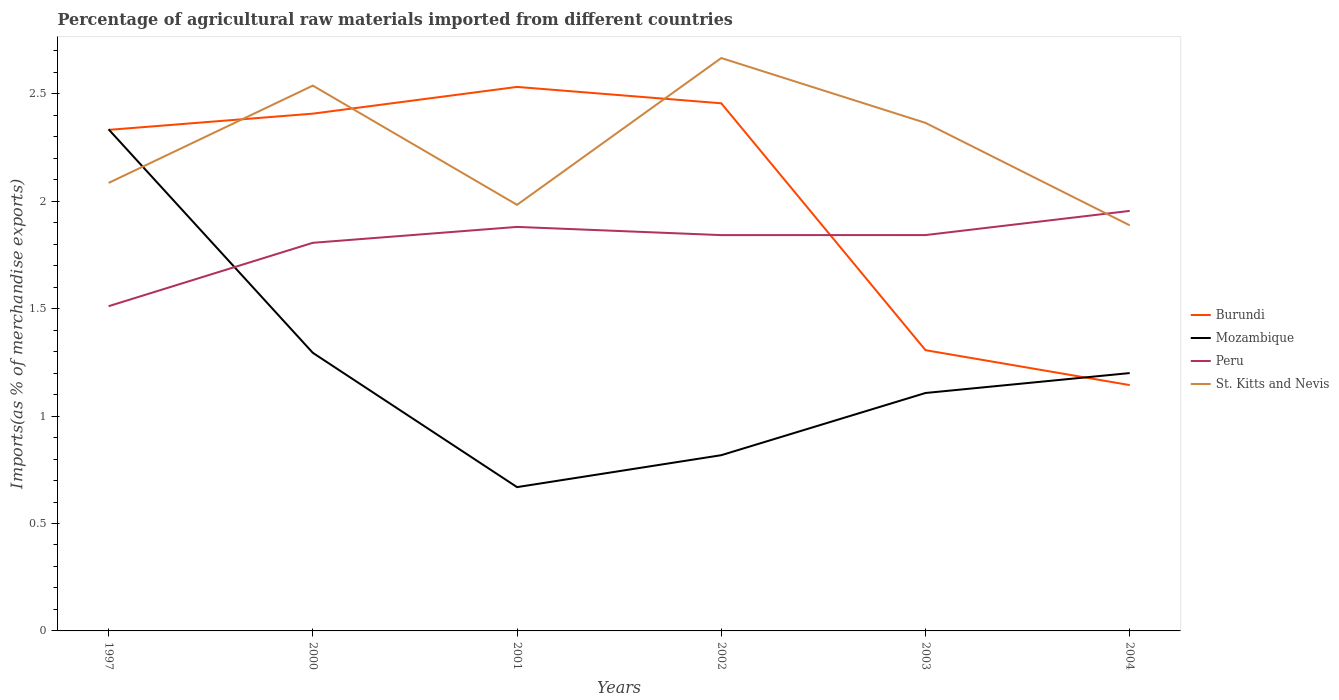Across all years, what is the maximum percentage of imports to different countries in Burundi?
Your answer should be compact. 1.14. In which year was the percentage of imports to different countries in Peru maximum?
Keep it short and to the point. 1997. What is the total percentage of imports to different countries in St. Kitts and Nevis in the graph?
Offer a terse response. -0.45. What is the difference between the highest and the second highest percentage of imports to different countries in St. Kitts and Nevis?
Keep it short and to the point. 0.78. What is the difference between the highest and the lowest percentage of imports to different countries in Burundi?
Provide a succinct answer. 4. Is the percentage of imports to different countries in St. Kitts and Nevis strictly greater than the percentage of imports to different countries in Burundi over the years?
Offer a terse response. No. How many lines are there?
Offer a terse response. 4. How many years are there in the graph?
Ensure brevity in your answer.  6. Does the graph contain any zero values?
Your response must be concise. No. Does the graph contain grids?
Your answer should be very brief. No. Where does the legend appear in the graph?
Provide a succinct answer. Center right. How many legend labels are there?
Give a very brief answer. 4. How are the legend labels stacked?
Offer a very short reply. Vertical. What is the title of the graph?
Keep it short and to the point. Percentage of agricultural raw materials imported from different countries. What is the label or title of the Y-axis?
Your answer should be compact. Imports(as % of merchandise exports). What is the Imports(as % of merchandise exports) of Burundi in 1997?
Provide a short and direct response. 2.33. What is the Imports(as % of merchandise exports) in Mozambique in 1997?
Ensure brevity in your answer.  2.33. What is the Imports(as % of merchandise exports) of Peru in 1997?
Provide a succinct answer. 1.51. What is the Imports(as % of merchandise exports) of St. Kitts and Nevis in 1997?
Offer a terse response. 2.09. What is the Imports(as % of merchandise exports) of Burundi in 2000?
Offer a very short reply. 2.41. What is the Imports(as % of merchandise exports) of Mozambique in 2000?
Give a very brief answer. 1.29. What is the Imports(as % of merchandise exports) of Peru in 2000?
Offer a very short reply. 1.81. What is the Imports(as % of merchandise exports) of St. Kitts and Nevis in 2000?
Your response must be concise. 2.54. What is the Imports(as % of merchandise exports) in Burundi in 2001?
Offer a very short reply. 2.53. What is the Imports(as % of merchandise exports) of Mozambique in 2001?
Your answer should be very brief. 0.67. What is the Imports(as % of merchandise exports) in Peru in 2001?
Ensure brevity in your answer.  1.88. What is the Imports(as % of merchandise exports) of St. Kitts and Nevis in 2001?
Provide a short and direct response. 1.98. What is the Imports(as % of merchandise exports) of Burundi in 2002?
Provide a short and direct response. 2.46. What is the Imports(as % of merchandise exports) in Mozambique in 2002?
Make the answer very short. 0.82. What is the Imports(as % of merchandise exports) of Peru in 2002?
Your response must be concise. 1.84. What is the Imports(as % of merchandise exports) in St. Kitts and Nevis in 2002?
Provide a succinct answer. 2.67. What is the Imports(as % of merchandise exports) of Burundi in 2003?
Offer a terse response. 1.31. What is the Imports(as % of merchandise exports) of Mozambique in 2003?
Your answer should be compact. 1.11. What is the Imports(as % of merchandise exports) of Peru in 2003?
Ensure brevity in your answer.  1.84. What is the Imports(as % of merchandise exports) in St. Kitts and Nevis in 2003?
Provide a short and direct response. 2.36. What is the Imports(as % of merchandise exports) in Burundi in 2004?
Provide a short and direct response. 1.14. What is the Imports(as % of merchandise exports) in Mozambique in 2004?
Give a very brief answer. 1.2. What is the Imports(as % of merchandise exports) in Peru in 2004?
Offer a very short reply. 1.95. What is the Imports(as % of merchandise exports) of St. Kitts and Nevis in 2004?
Offer a very short reply. 1.89. Across all years, what is the maximum Imports(as % of merchandise exports) of Burundi?
Keep it short and to the point. 2.53. Across all years, what is the maximum Imports(as % of merchandise exports) of Mozambique?
Offer a terse response. 2.33. Across all years, what is the maximum Imports(as % of merchandise exports) in Peru?
Your answer should be very brief. 1.95. Across all years, what is the maximum Imports(as % of merchandise exports) of St. Kitts and Nevis?
Make the answer very short. 2.67. Across all years, what is the minimum Imports(as % of merchandise exports) of Burundi?
Provide a short and direct response. 1.14. Across all years, what is the minimum Imports(as % of merchandise exports) of Mozambique?
Provide a short and direct response. 0.67. Across all years, what is the minimum Imports(as % of merchandise exports) in Peru?
Your answer should be very brief. 1.51. Across all years, what is the minimum Imports(as % of merchandise exports) of St. Kitts and Nevis?
Your response must be concise. 1.89. What is the total Imports(as % of merchandise exports) of Burundi in the graph?
Your answer should be compact. 12.18. What is the total Imports(as % of merchandise exports) of Mozambique in the graph?
Provide a short and direct response. 7.42. What is the total Imports(as % of merchandise exports) in Peru in the graph?
Offer a very short reply. 10.84. What is the total Imports(as % of merchandise exports) of St. Kitts and Nevis in the graph?
Offer a terse response. 13.52. What is the difference between the Imports(as % of merchandise exports) in Burundi in 1997 and that in 2000?
Give a very brief answer. -0.08. What is the difference between the Imports(as % of merchandise exports) of Mozambique in 1997 and that in 2000?
Make the answer very short. 1.04. What is the difference between the Imports(as % of merchandise exports) in Peru in 1997 and that in 2000?
Offer a very short reply. -0.29. What is the difference between the Imports(as % of merchandise exports) in St. Kitts and Nevis in 1997 and that in 2000?
Give a very brief answer. -0.45. What is the difference between the Imports(as % of merchandise exports) in Burundi in 1997 and that in 2001?
Give a very brief answer. -0.2. What is the difference between the Imports(as % of merchandise exports) in Mozambique in 1997 and that in 2001?
Make the answer very short. 1.67. What is the difference between the Imports(as % of merchandise exports) in Peru in 1997 and that in 2001?
Give a very brief answer. -0.37. What is the difference between the Imports(as % of merchandise exports) in St. Kitts and Nevis in 1997 and that in 2001?
Provide a succinct answer. 0.1. What is the difference between the Imports(as % of merchandise exports) in Burundi in 1997 and that in 2002?
Offer a very short reply. -0.12. What is the difference between the Imports(as % of merchandise exports) in Mozambique in 1997 and that in 2002?
Your answer should be compact. 1.52. What is the difference between the Imports(as % of merchandise exports) in Peru in 1997 and that in 2002?
Offer a very short reply. -0.33. What is the difference between the Imports(as % of merchandise exports) in St. Kitts and Nevis in 1997 and that in 2002?
Your answer should be compact. -0.58. What is the difference between the Imports(as % of merchandise exports) of Burundi in 1997 and that in 2003?
Keep it short and to the point. 1.03. What is the difference between the Imports(as % of merchandise exports) in Mozambique in 1997 and that in 2003?
Give a very brief answer. 1.23. What is the difference between the Imports(as % of merchandise exports) in Peru in 1997 and that in 2003?
Make the answer very short. -0.33. What is the difference between the Imports(as % of merchandise exports) of St. Kitts and Nevis in 1997 and that in 2003?
Offer a very short reply. -0.28. What is the difference between the Imports(as % of merchandise exports) of Burundi in 1997 and that in 2004?
Ensure brevity in your answer.  1.19. What is the difference between the Imports(as % of merchandise exports) in Mozambique in 1997 and that in 2004?
Offer a very short reply. 1.13. What is the difference between the Imports(as % of merchandise exports) of Peru in 1997 and that in 2004?
Your answer should be compact. -0.44. What is the difference between the Imports(as % of merchandise exports) in St. Kitts and Nevis in 1997 and that in 2004?
Your answer should be compact. 0.2. What is the difference between the Imports(as % of merchandise exports) of Burundi in 2000 and that in 2001?
Ensure brevity in your answer.  -0.12. What is the difference between the Imports(as % of merchandise exports) of Mozambique in 2000 and that in 2001?
Ensure brevity in your answer.  0.62. What is the difference between the Imports(as % of merchandise exports) in Peru in 2000 and that in 2001?
Keep it short and to the point. -0.07. What is the difference between the Imports(as % of merchandise exports) in St. Kitts and Nevis in 2000 and that in 2001?
Provide a succinct answer. 0.55. What is the difference between the Imports(as % of merchandise exports) of Burundi in 2000 and that in 2002?
Offer a terse response. -0.05. What is the difference between the Imports(as % of merchandise exports) in Mozambique in 2000 and that in 2002?
Provide a succinct answer. 0.48. What is the difference between the Imports(as % of merchandise exports) in Peru in 2000 and that in 2002?
Offer a very short reply. -0.04. What is the difference between the Imports(as % of merchandise exports) of St. Kitts and Nevis in 2000 and that in 2002?
Your answer should be very brief. -0.13. What is the difference between the Imports(as % of merchandise exports) of Burundi in 2000 and that in 2003?
Provide a short and direct response. 1.1. What is the difference between the Imports(as % of merchandise exports) of Mozambique in 2000 and that in 2003?
Ensure brevity in your answer.  0.19. What is the difference between the Imports(as % of merchandise exports) of Peru in 2000 and that in 2003?
Keep it short and to the point. -0.04. What is the difference between the Imports(as % of merchandise exports) of St. Kitts and Nevis in 2000 and that in 2003?
Provide a short and direct response. 0.17. What is the difference between the Imports(as % of merchandise exports) in Burundi in 2000 and that in 2004?
Your answer should be compact. 1.26. What is the difference between the Imports(as % of merchandise exports) in Mozambique in 2000 and that in 2004?
Give a very brief answer. 0.09. What is the difference between the Imports(as % of merchandise exports) of Peru in 2000 and that in 2004?
Your response must be concise. -0.15. What is the difference between the Imports(as % of merchandise exports) in St. Kitts and Nevis in 2000 and that in 2004?
Make the answer very short. 0.65. What is the difference between the Imports(as % of merchandise exports) of Burundi in 2001 and that in 2002?
Give a very brief answer. 0.08. What is the difference between the Imports(as % of merchandise exports) of Mozambique in 2001 and that in 2002?
Provide a short and direct response. -0.15. What is the difference between the Imports(as % of merchandise exports) in Peru in 2001 and that in 2002?
Provide a short and direct response. 0.04. What is the difference between the Imports(as % of merchandise exports) in St. Kitts and Nevis in 2001 and that in 2002?
Provide a short and direct response. -0.68. What is the difference between the Imports(as % of merchandise exports) of Burundi in 2001 and that in 2003?
Your answer should be compact. 1.23. What is the difference between the Imports(as % of merchandise exports) in Mozambique in 2001 and that in 2003?
Your answer should be very brief. -0.44. What is the difference between the Imports(as % of merchandise exports) in Peru in 2001 and that in 2003?
Your response must be concise. 0.04. What is the difference between the Imports(as % of merchandise exports) in St. Kitts and Nevis in 2001 and that in 2003?
Give a very brief answer. -0.38. What is the difference between the Imports(as % of merchandise exports) of Burundi in 2001 and that in 2004?
Your response must be concise. 1.39. What is the difference between the Imports(as % of merchandise exports) of Mozambique in 2001 and that in 2004?
Offer a terse response. -0.53. What is the difference between the Imports(as % of merchandise exports) in Peru in 2001 and that in 2004?
Your response must be concise. -0.07. What is the difference between the Imports(as % of merchandise exports) in St. Kitts and Nevis in 2001 and that in 2004?
Provide a succinct answer. 0.1. What is the difference between the Imports(as % of merchandise exports) in Burundi in 2002 and that in 2003?
Ensure brevity in your answer.  1.15. What is the difference between the Imports(as % of merchandise exports) of Mozambique in 2002 and that in 2003?
Ensure brevity in your answer.  -0.29. What is the difference between the Imports(as % of merchandise exports) of Peru in 2002 and that in 2003?
Ensure brevity in your answer.  -0. What is the difference between the Imports(as % of merchandise exports) in St. Kitts and Nevis in 2002 and that in 2003?
Provide a short and direct response. 0.3. What is the difference between the Imports(as % of merchandise exports) of Burundi in 2002 and that in 2004?
Make the answer very short. 1.31. What is the difference between the Imports(as % of merchandise exports) in Mozambique in 2002 and that in 2004?
Provide a succinct answer. -0.38. What is the difference between the Imports(as % of merchandise exports) of Peru in 2002 and that in 2004?
Give a very brief answer. -0.11. What is the difference between the Imports(as % of merchandise exports) of St. Kitts and Nevis in 2002 and that in 2004?
Ensure brevity in your answer.  0.78. What is the difference between the Imports(as % of merchandise exports) of Burundi in 2003 and that in 2004?
Offer a very short reply. 0.16. What is the difference between the Imports(as % of merchandise exports) in Mozambique in 2003 and that in 2004?
Give a very brief answer. -0.09. What is the difference between the Imports(as % of merchandise exports) of Peru in 2003 and that in 2004?
Keep it short and to the point. -0.11. What is the difference between the Imports(as % of merchandise exports) of St. Kitts and Nevis in 2003 and that in 2004?
Provide a succinct answer. 0.48. What is the difference between the Imports(as % of merchandise exports) of Burundi in 1997 and the Imports(as % of merchandise exports) of Mozambique in 2000?
Your answer should be compact. 1.04. What is the difference between the Imports(as % of merchandise exports) in Burundi in 1997 and the Imports(as % of merchandise exports) in Peru in 2000?
Your answer should be very brief. 0.53. What is the difference between the Imports(as % of merchandise exports) in Burundi in 1997 and the Imports(as % of merchandise exports) in St. Kitts and Nevis in 2000?
Make the answer very short. -0.21. What is the difference between the Imports(as % of merchandise exports) in Mozambique in 1997 and the Imports(as % of merchandise exports) in Peru in 2000?
Ensure brevity in your answer.  0.53. What is the difference between the Imports(as % of merchandise exports) of Mozambique in 1997 and the Imports(as % of merchandise exports) of St. Kitts and Nevis in 2000?
Give a very brief answer. -0.2. What is the difference between the Imports(as % of merchandise exports) of Peru in 1997 and the Imports(as % of merchandise exports) of St. Kitts and Nevis in 2000?
Keep it short and to the point. -1.03. What is the difference between the Imports(as % of merchandise exports) of Burundi in 1997 and the Imports(as % of merchandise exports) of Mozambique in 2001?
Keep it short and to the point. 1.66. What is the difference between the Imports(as % of merchandise exports) in Burundi in 1997 and the Imports(as % of merchandise exports) in Peru in 2001?
Make the answer very short. 0.45. What is the difference between the Imports(as % of merchandise exports) in Burundi in 1997 and the Imports(as % of merchandise exports) in St. Kitts and Nevis in 2001?
Keep it short and to the point. 0.35. What is the difference between the Imports(as % of merchandise exports) of Mozambique in 1997 and the Imports(as % of merchandise exports) of Peru in 2001?
Your answer should be very brief. 0.45. What is the difference between the Imports(as % of merchandise exports) of Mozambique in 1997 and the Imports(as % of merchandise exports) of St. Kitts and Nevis in 2001?
Make the answer very short. 0.35. What is the difference between the Imports(as % of merchandise exports) in Peru in 1997 and the Imports(as % of merchandise exports) in St. Kitts and Nevis in 2001?
Offer a terse response. -0.47. What is the difference between the Imports(as % of merchandise exports) of Burundi in 1997 and the Imports(as % of merchandise exports) of Mozambique in 2002?
Provide a succinct answer. 1.51. What is the difference between the Imports(as % of merchandise exports) in Burundi in 1997 and the Imports(as % of merchandise exports) in Peru in 2002?
Make the answer very short. 0.49. What is the difference between the Imports(as % of merchandise exports) of Burundi in 1997 and the Imports(as % of merchandise exports) of St. Kitts and Nevis in 2002?
Give a very brief answer. -0.33. What is the difference between the Imports(as % of merchandise exports) of Mozambique in 1997 and the Imports(as % of merchandise exports) of Peru in 2002?
Provide a succinct answer. 0.49. What is the difference between the Imports(as % of merchandise exports) in Mozambique in 1997 and the Imports(as % of merchandise exports) in St. Kitts and Nevis in 2002?
Provide a short and direct response. -0.33. What is the difference between the Imports(as % of merchandise exports) in Peru in 1997 and the Imports(as % of merchandise exports) in St. Kitts and Nevis in 2002?
Ensure brevity in your answer.  -1.16. What is the difference between the Imports(as % of merchandise exports) in Burundi in 1997 and the Imports(as % of merchandise exports) in Mozambique in 2003?
Keep it short and to the point. 1.22. What is the difference between the Imports(as % of merchandise exports) of Burundi in 1997 and the Imports(as % of merchandise exports) of Peru in 2003?
Your answer should be compact. 0.49. What is the difference between the Imports(as % of merchandise exports) in Burundi in 1997 and the Imports(as % of merchandise exports) in St. Kitts and Nevis in 2003?
Make the answer very short. -0.03. What is the difference between the Imports(as % of merchandise exports) of Mozambique in 1997 and the Imports(as % of merchandise exports) of Peru in 2003?
Give a very brief answer. 0.49. What is the difference between the Imports(as % of merchandise exports) in Mozambique in 1997 and the Imports(as % of merchandise exports) in St. Kitts and Nevis in 2003?
Your answer should be compact. -0.03. What is the difference between the Imports(as % of merchandise exports) in Peru in 1997 and the Imports(as % of merchandise exports) in St. Kitts and Nevis in 2003?
Make the answer very short. -0.85. What is the difference between the Imports(as % of merchandise exports) of Burundi in 1997 and the Imports(as % of merchandise exports) of Mozambique in 2004?
Provide a short and direct response. 1.13. What is the difference between the Imports(as % of merchandise exports) of Burundi in 1997 and the Imports(as % of merchandise exports) of Peru in 2004?
Keep it short and to the point. 0.38. What is the difference between the Imports(as % of merchandise exports) in Burundi in 1997 and the Imports(as % of merchandise exports) in St. Kitts and Nevis in 2004?
Provide a short and direct response. 0.44. What is the difference between the Imports(as % of merchandise exports) of Mozambique in 1997 and the Imports(as % of merchandise exports) of Peru in 2004?
Your answer should be very brief. 0.38. What is the difference between the Imports(as % of merchandise exports) of Mozambique in 1997 and the Imports(as % of merchandise exports) of St. Kitts and Nevis in 2004?
Your answer should be compact. 0.45. What is the difference between the Imports(as % of merchandise exports) in Peru in 1997 and the Imports(as % of merchandise exports) in St. Kitts and Nevis in 2004?
Offer a very short reply. -0.38. What is the difference between the Imports(as % of merchandise exports) of Burundi in 2000 and the Imports(as % of merchandise exports) of Mozambique in 2001?
Make the answer very short. 1.74. What is the difference between the Imports(as % of merchandise exports) of Burundi in 2000 and the Imports(as % of merchandise exports) of Peru in 2001?
Keep it short and to the point. 0.53. What is the difference between the Imports(as % of merchandise exports) of Burundi in 2000 and the Imports(as % of merchandise exports) of St. Kitts and Nevis in 2001?
Your answer should be very brief. 0.42. What is the difference between the Imports(as % of merchandise exports) in Mozambique in 2000 and the Imports(as % of merchandise exports) in Peru in 2001?
Offer a very short reply. -0.59. What is the difference between the Imports(as % of merchandise exports) of Mozambique in 2000 and the Imports(as % of merchandise exports) of St. Kitts and Nevis in 2001?
Make the answer very short. -0.69. What is the difference between the Imports(as % of merchandise exports) of Peru in 2000 and the Imports(as % of merchandise exports) of St. Kitts and Nevis in 2001?
Your response must be concise. -0.18. What is the difference between the Imports(as % of merchandise exports) of Burundi in 2000 and the Imports(as % of merchandise exports) of Mozambique in 2002?
Your answer should be compact. 1.59. What is the difference between the Imports(as % of merchandise exports) of Burundi in 2000 and the Imports(as % of merchandise exports) of Peru in 2002?
Offer a terse response. 0.57. What is the difference between the Imports(as % of merchandise exports) in Burundi in 2000 and the Imports(as % of merchandise exports) in St. Kitts and Nevis in 2002?
Your response must be concise. -0.26. What is the difference between the Imports(as % of merchandise exports) of Mozambique in 2000 and the Imports(as % of merchandise exports) of Peru in 2002?
Keep it short and to the point. -0.55. What is the difference between the Imports(as % of merchandise exports) of Mozambique in 2000 and the Imports(as % of merchandise exports) of St. Kitts and Nevis in 2002?
Keep it short and to the point. -1.37. What is the difference between the Imports(as % of merchandise exports) in Peru in 2000 and the Imports(as % of merchandise exports) in St. Kitts and Nevis in 2002?
Ensure brevity in your answer.  -0.86. What is the difference between the Imports(as % of merchandise exports) in Burundi in 2000 and the Imports(as % of merchandise exports) in Mozambique in 2003?
Keep it short and to the point. 1.3. What is the difference between the Imports(as % of merchandise exports) of Burundi in 2000 and the Imports(as % of merchandise exports) of Peru in 2003?
Ensure brevity in your answer.  0.57. What is the difference between the Imports(as % of merchandise exports) in Burundi in 2000 and the Imports(as % of merchandise exports) in St. Kitts and Nevis in 2003?
Offer a very short reply. 0.04. What is the difference between the Imports(as % of merchandise exports) in Mozambique in 2000 and the Imports(as % of merchandise exports) in Peru in 2003?
Give a very brief answer. -0.55. What is the difference between the Imports(as % of merchandise exports) in Mozambique in 2000 and the Imports(as % of merchandise exports) in St. Kitts and Nevis in 2003?
Keep it short and to the point. -1.07. What is the difference between the Imports(as % of merchandise exports) of Peru in 2000 and the Imports(as % of merchandise exports) of St. Kitts and Nevis in 2003?
Give a very brief answer. -0.56. What is the difference between the Imports(as % of merchandise exports) in Burundi in 2000 and the Imports(as % of merchandise exports) in Mozambique in 2004?
Provide a succinct answer. 1.21. What is the difference between the Imports(as % of merchandise exports) of Burundi in 2000 and the Imports(as % of merchandise exports) of Peru in 2004?
Give a very brief answer. 0.45. What is the difference between the Imports(as % of merchandise exports) of Burundi in 2000 and the Imports(as % of merchandise exports) of St. Kitts and Nevis in 2004?
Give a very brief answer. 0.52. What is the difference between the Imports(as % of merchandise exports) in Mozambique in 2000 and the Imports(as % of merchandise exports) in Peru in 2004?
Offer a very short reply. -0.66. What is the difference between the Imports(as % of merchandise exports) of Mozambique in 2000 and the Imports(as % of merchandise exports) of St. Kitts and Nevis in 2004?
Ensure brevity in your answer.  -0.59. What is the difference between the Imports(as % of merchandise exports) in Peru in 2000 and the Imports(as % of merchandise exports) in St. Kitts and Nevis in 2004?
Provide a succinct answer. -0.08. What is the difference between the Imports(as % of merchandise exports) in Burundi in 2001 and the Imports(as % of merchandise exports) in Mozambique in 2002?
Your answer should be compact. 1.71. What is the difference between the Imports(as % of merchandise exports) of Burundi in 2001 and the Imports(as % of merchandise exports) of Peru in 2002?
Offer a terse response. 0.69. What is the difference between the Imports(as % of merchandise exports) in Burundi in 2001 and the Imports(as % of merchandise exports) in St. Kitts and Nevis in 2002?
Give a very brief answer. -0.13. What is the difference between the Imports(as % of merchandise exports) in Mozambique in 2001 and the Imports(as % of merchandise exports) in Peru in 2002?
Provide a succinct answer. -1.17. What is the difference between the Imports(as % of merchandise exports) of Mozambique in 2001 and the Imports(as % of merchandise exports) of St. Kitts and Nevis in 2002?
Keep it short and to the point. -2. What is the difference between the Imports(as % of merchandise exports) of Peru in 2001 and the Imports(as % of merchandise exports) of St. Kitts and Nevis in 2002?
Your answer should be very brief. -0.79. What is the difference between the Imports(as % of merchandise exports) of Burundi in 2001 and the Imports(as % of merchandise exports) of Mozambique in 2003?
Your response must be concise. 1.42. What is the difference between the Imports(as % of merchandise exports) in Burundi in 2001 and the Imports(as % of merchandise exports) in Peru in 2003?
Offer a terse response. 0.69. What is the difference between the Imports(as % of merchandise exports) of Burundi in 2001 and the Imports(as % of merchandise exports) of St. Kitts and Nevis in 2003?
Ensure brevity in your answer.  0.17. What is the difference between the Imports(as % of merchandise exports) of Mozambique in 2001 and the Imports(as % of merchandise exports) of Peru in 2003?
Offer a very short reply. -1.17. What is the difference between the Imports(as % of merchandise exports) of Mozambique in 2001 and the Imports(as % of merchandise exports) of St. Kitts and Nevis in 2003?
Your answer should be very brief. -1.7. What is the difference between the Imports(as % of merchandise exports) in Peru in 2001 and the Imports(as % of merchandise exports) in St. Kitts and Nevis in 2003?
Ensure brevity in your answer.  -0.48. What is the difference between the Imports(as % of merchandise exports) in Burundi in 2001 and the Imports(as % of merchandise exports) in Mozambique in 2004?
Keep it short and to the point. 1.33. What is the difference between the Imports(as % of merchandise exports) of Burundi in 2001 and the Imports(as % of merchandise exports) of Peru in 2004?
Keep it short and to the point. 0.58. What is the difference between the Imports(as % of merchandise exports) of Burundi in 2001 and the Imports(as % of merchandise exports) of St. Kitts and Nevis in 2004?
Give a very brief answer. 0.64. What is the difference between the Imports(as % of merchandise exports) of Mozambique in 2001 and the Imports(as % of merchandise exports) of Peru in 2004?
Make the answer very short. -1.29. What is the difference between the Imports(as % of merchandise exports) of Mozambique in 2001 and the Imports(as % of merchandise exports) of St. Kitts and Nevis in 2004?
Your answer should be very brief. -1.22. What is the difference between the Imports(as % of merchandise exports) in Peru in 2001 and the Imports(as % of merchandise exports) in St. Kitts and Nevis in 2004?
Offer a terse response. -0.01. What is the difference between the Imports(as % of merchandise exports) in Burundi in 2002 and the Imports(as % of merchandise exports) in Mozambique in 2003?
Provide a succinct answer. 1.35. What is the difference between the Imports(as % of merchandise exports) of Burundi in 2002 and the Imports(as % of merchandise exports) of Peru in 2003?
Offer a terse response. 0.61. What is the difference between the Imports(as % of merchandise exports) in Burundi in 2002 and the Imports(as % of merchandise exports) in St. Kitts and Nevis in 2003?
Provide a succinct answer. 0.09. What is the difference between the Imports(as % of merchandise exports) in Mozambique in 2002 and the Imports(as % of merchandise exports) in Peru in 2003?
Your answer should be compact. -1.02. What is the difference between the Imports(as % of merchandise exports) in Mozambique in 2002 and the Imports(as % of merchandise exports) in St. Kitts and Nevis in 2003?
Provide a short and direct response. -1.55. What is the difference between the Imports(as % of merchandise exports) in Peru in 2002 and the Imports(as % of merchandise exports) in St. Kitts and Nevis in 2003?
Provide a succinct answer. -0.52. What is the difference between the Imports(as % of merchandise exports) in Burundi in 2002 and the Imports(as % of merchandise exports) in Mozambique in 2004?
Keep it short and to the point. 1.26. What is the difference between the Imports(as % of merchandise exports) in Burundi in 2002 and the Imports(as % of merchandise exports) in Peru in 2004?
Your response must be concise. 0.5. What is the difference between the Imports(as % of merchandise exports) in Burundi in 2002 and the Imports(as % of merchandise exports) in St. Kitts and Nevis in 2004?
Ensure brevity in your answer.  0.57. What is the difference between the Imports(as % of merchandise exports) of Mozambique in 2002 and the Imports(as % of merchandise exports) of Peru in 2004?
Provide a succinct answer. -1.14. What is the difference between the Imports(as % of merchandise exports) of Mozambique in 2002 and the Imports(as % of merchandise exports) of St. Kitts and Nevis in 2004?
Offer a terse response. -1.07. What is the difference between the Imports(as % of merchandise exports) in Peru in 2002 and the Imports(as % of merchandise exports) in St. Kitts and Nevis in 2004?
Give a very brief answer. -0.05. What is the difference between the Imports(as % of merchandise exports) in Burundi in 2003 and the Imports(as % of merchandise exports) in Mozambique in 2004?
Provide a short and direct response. 0.11. What is the difference between the Imports(as % of merchandise exports) of Burundi in 2003 and the Imports(as % of merchandise exports) of Peru in 2004?
Ensure brevity in your answer.  -0.65. What is the difference between the Imports(as % of merchandise exports) of Burundi in 2003 and the Imports(as % of merchandise exports) of St. Kitts and Nevis in 2004?
Provide a short and direct response. -0.58. What is the difference between the Imports(as % of merchandise exports) of Mozambique in 2003 and the Imports(as % of merchandise exports) of Peru in 2004?
Give a very brief answer. -0.85. What is the difference between the Imports(as % of merchandise exports) of Mozambique in 2003 and the Imports(as % of merchandise exports) of St. Kitts and Nevis in 2004?
Your answer should be very brief. -0.78. What is the difference between the Imports(as % of merchandise exports) in Peru in 2003 and the Imports(as % of merchandise exports) in St. Kitts and Nevis in 2004?
Keep it short and to the point. -0.05. What is the average Imports(as % of merchandise exports) in Burundi per year?
Provide a short and direct response. 2.03. What is the average Imports(as % of merchandise exports) in Mozambique per year?
Your answer should be compact. 1.24. What is the average Imports(as % of merchandise exports) of Peru per year?
Ensure brevity in your answer.  1.81. What is the average Imports(as % of merchandise exports) in St. Kitts and Nevis per year?
Provide a succinct answer. 2.25. In the year 1997, what is the difference between the Imports(as % of merchandise exports) of Burundi and Imports(as % of merchandise exports) of Mozambique?
Provide a succinct answer. -0. In the year 1997, what is the difference between the Imports(as % of merchandise exports) of Burundi and Imports(as % of merchandise exports) of Peru?
Offer a very short reply. 0.82. In the year 1997, what is the difference between the Imports(as % of merchandise exports) of Burundi and Imports(as % of merchandise exports) of St. Kitts and Nevis?
Keep it short and to the point. 0.25. In the year 1997, what is the difference between the Imports(as % of merchandise exports) of Mozambique and Imports(as % of merchandise exports) of Peru?
Give a very brief answer. 0.82. In the year 1997, what is the difference between the Imports(as % of merchandise exports) in Mozambique and Imports(as % of merchandise exports) in St. Kitts and Nevis?
Your answer should be very brief. 0.25. In the year 1997, what is the difference between the Imports(as % of merchandise exports) in Peru and Imports(as % of merchandise exports) in St. Kitts and Nevis?
Ensure brevity in your answer.  -0.57. In the year 2000, what is the difference between the Imports(as % of merchandise exports) in Burundi and Imports(as % of merchandise exports) in Mozambique?
Your answer should be very brief. 1.11. In the year 2000, what is the difference between the Imports(as % of merchandise exports) of Burundi and Imports(as % of merchandise exports) of Peru?
Keep it short and to the point. 0.6. In the year 2000, what is the difference between the Imports(as % of merchandise exports) of Burundi and Imports(as % of merchandise exports) of St. Kitts and Nevis?
Offer a very short reply. -0.13. In the year 2000, what is the difference between the Imports(as % of merchandise exports) in Mozambique and Imports(as % of merchandise exports) in Peru?
Provide a succinct answer. -0.51. In the year 2000, what is the difference between the Imports(as % of merchandise exports) in Mozambique and Imports(as % of merchandise exports) in St. Kitts and Nevis?
Your response must be concise. -1.24. In the year 2000, what is the difference between the Imports(as % of merchandise exports) in Peru and Imports(as % of merchandise exports) in St. Kitts and Nevis?
Offer a very short reply. -0.73. In the year 2001, what is the difference between the Imports(as % of merchandise exports) of Burundi and Imports(as % of merchandise exports) of Mozambique?
Provide a short and direct response. 1.86. In the year 2001, what is the difference between the Imports(as % of merchandise exports) in Burundi and Imports(as % of merchandise exports) in Peru?
Your answer should be very brief. 0.65. In the year 2001, what is the difference between the Imports(as % of merchandise exports) in Burundi and Imports(as % of merchandise exports) in St. Kitts and Nevis?
Your answer should be compact. 0.55. In the year 2001, what is the difference between the Imports(as % of merchandise exports) of Mozambique and Imports(as % of merchandise exports) of Peru?
Offer a terse response. -1.21. In the year 2001, what is the difference between the Imports(as % of merchandise exports) in Mozambique and Imports(as % of merchandise exports) in St. Kitts and Nevis?
Keep it short and to the point. -1.31. In the year 2001, what is the difference between the Imports(as % of merchandise exports) of Peru and Imports(as % of merchandise exports) of St. Kitts and Nevis?
Make the answer very short. -0.1. In the year 2002, what is the difference between the Imports(as % of merchandise exports) of Burundi and Imports(as % of merchandise exports) of Mozambique?
Ensure brevity in your answer.  1.64. In the year 2002, what is the difference between the Imports(as % of merchandise exports) in Burundi and Imports(as % of merchandise exports) in Peru?
Provide a succinct answer. 0.61. In the year 2002, what is the difference between the Imports(as % of merchandise exports) in Burundi and Imports(as % of merchandise exports) in St. Kitts and Nevis?
Offer a very short reply. -0.21. In the year 2002, what is the difference between the Imports(as % of merchandise exports) in Mozambique and Imports(as % of merchandise exports) in Peru?
Keep it short and to the point. -1.02. In the year 2002, what is the difference between the Imports(as % of merchandise exports) of Mozambique and Imports(as % of merchandise exports) of St. Kitts and Nevis?
Your response must be concise. -1.85. In the year 2002, what is the difference between the Imports(as % of merchandise exports) of Peru and Imports(as % of merchandise exports) of St. Kitts and Nevis?
Ensure brevity in your answer.  -0.82. In the year 2003, what is the difference between the Imports(as % of merchandise exports) of Burundi and Imports(as % of merchandise exports) of Mozambique?
Provide a succinct answer. 0.2. In the year 2003, what is the difference between the Imports(as % of merchandise exports) of Burundi and Imports(as % of merchandise exports) of Peru?
Provide a succinct answer. -0.54. In the year 2003, what is the difference between the Imports(as % of merchandise exports) in Burundi and Imports(as % of merchandise exports) in St. Kitts and Nevis?
Give a very brief answer. -1.06. In the year 2003, what is the difference between the Imports(as % of merchandise exports) in Mozambique and Imports(as % of merchandise exports) in Peru?
Keep it short and to the point. -0.73. In the year 2003, what is the difference between the Imports(as % of merchandise exports) in Mozambique and Imports(as % of merchandise exports) in St. Kitts and Nevis?
Your answer should be compact. -1.26. In the year 2003, what is the difference between the Imports(as % of merchandise exports) of Peru and Imports(as % of merchandise exports) of St. Kitts and Nevis?
Make the answer very short. -0.52. In the year 2004, what is the difference between the Imports(as % of merchandise exports) of Burundi and Imports(as % of merchandise exports) of Mozambique?
Give a very brief answer. -0.06. In the year 2004, what is the difference between the Imports(as % of merchandise exports) in Burundi and Imports(as % of merchandise exports) in Peru?
Offer a very short reply. -0.81. In the year 2004, what is the difference between the Imports(as % of merchandise exports) in Burundi and Imports(as % of merchandise exports) in St. Kitts and Nevis?
Your answer should be very brief. -0.74. In the year 2004, what is the difference between the Imports(as % of merchandise exports) of Mozambique and Imports(as % of merchandise exports) of Peru?
Keep it short and to the point. -0.75. In the year 2004, what is the difference between the Imports(as % of merchandise exports) in Mozambique and Imports(as % of merchandise exports) in St. Kitts and Nevis?
Your answer should be compact. -0.69. In the year 2004, what is the difference between the Imports(as % of merchandise exports) of Peru and Imports(as % of merchandise exports) of St. Kitts and Nevis?
Make the answer very short. 0.07. What is the ratio of the Imports(as % of merchandise exports) in Burundi in 1997 to that in 2000?
Your answer should be compact. 0.97. What is the ratio of the Imports(as % of merchandise exports) in Mozambique in 1997 to that in 2000?
Keep it short and to the point. 1.8. What is the ratio of the Imports(as % of merchandise exports) in Peru in 1997 to that in 2000?
Make the answer very short. 0.84. What is the ratio of the Imports(as % of merchandise exports) of St. Kitts and Nevis in 1997 to that in 2000?
Provide a short and direct response. 0.82. What is the ratio of the Imports(as % of merchandise exports) of Burundi in 1997 to that in 2001?
Your answer should be very brief. 0.92. What is the ratio of the Imports(as % of merchandise exports) of Mozambique in 1997 to that in 2001?
Your answer should be compact. 3.49. What is the ratio of the Imports(as % of merchandise exports) in Peru in 1997 to that in 2001?
Offer a very short reply. 0.8. What is the ratio of the Imports(as % of merchandise exports) of St. Kitts and Nevis in 1997 to that in 2001?
Offer a terse response. 1.05. What is the ratio of the Imports(as % of merchandise exports) in Burundi in 1997 to that in 2002?
Offer a very short reply. 0.95. What is the ratio of the Imports(as % of merchandise exports) of Mozambique in 1997 to that in 2002?
Your response must be concise. 2.85. What is the ratio of the Imports(as % of merchandise exports) in Peru in 1997 to that in 2002?
Keep it short and to the point. 0.82. What is the ratio of the Imports(as % of merchandise exports) of St. Kitts and Nevis in 1997 to that in 2002?
Give a very brief answer. 0.78. What is the ratio of the Imports(as % of merchandise exports) in Burundi in 1997 to that in 2003?
Your answer should be very brief. 1.78. What is the ratio of the Imports(as % of merchandise exports) of Mozambique in 1997 to that in 2003?
Provide a short and direct response. 2.11. What is the ratio of the Imports(as % of merchandise exports) of Peru in 1997 to that in 2003?
Ensure brevity in your answer.  0.82. What is the ratio of the Imports(as % of merchandise exports) of St. Kitts and Nevis in 1997 to that in 2003?
Your answer should be very brief. 0.88. What is the ratio of the Imports(as % of merchandise exports) of Burundi in 1997 to that in 2004?
Give a very brief answer. 2.04. What is the ratio of the Imports(as % of merchandise exports) of Mozambique in 1997 to that in 2004?
Provide a short and direct response. 1.95. What is the ratio of the Imports(as % of merchandise exports) of Peru in 1997 to that in 2004?
Your answer should be very brief. 0.77. What is the ratio of the Imports(as % of merchandise exports) of St. Kitts and Nevis in 1997 to that in 2004?
Provide a short and direct response. 1.1. What is the ratio of the Imports(as % of merchandise exports) of Burundi in 2000 to that in 2001?
Your answer should be compact. 0.95. What is the ratio of the Imports(as % of merchandise exports) in Mozambique in 2000 to that in 2001?
Ensure brevity in your answer.  1.93. What is the ratio of the Imports(as % of merchandise exports) in Peru in 2000 to that in 2001?
Keep it short and to the point. 0.96. What is the ratio of the Imports(as % of merchandise exports) of St. Kitts and Nevis in 2000 to that in 2001?
Offer a terse response. 1.28. What is the ratio of the Imports(as % of merchandise exports) in Burundi in 2000 to that in 2002?
Provide a short and direct response. 0.98. What is the ratio of the Imports(as % of merchandise exports) of Mozambique in 2000 to that in 2002?
Keep it short and to the point. 1.58. What is the ratio of the Imports(as % of merchandise exports) of Peru in 2000 to that in 2002?
Offer a terse response. 0.98. What is the ratio of the Imports(as % of merchandise exports) in St. Kitts and Nevis in 2000 to that in 2002?
Give a very brief answer. 0.95. What is the ratio of the Imports(as % of merchandise exports) of Burundi in 2000 to that in 2003?
Give a very brief answer. 1.84. What is the ratio of the Imports(as % of merchandise exports) in Mozambique in 2000 to that in 2003?
Offer a terse response. 1.17. What is the ratio of the Imports(as % of merchandise exports) of Peru in 2000 to that in 2003?
Provide a short and direct response. 0.98. What is the ratio of the Imports(as % of merchandise exports) of St. Kitts and Nevis in 2000 to that in 2003?
Your response must be concise. 1.07. What is the ratio of the Imports(as % of merchandise exports) in Burundi in 2000 to that in 2004?
Provide a short and direct response. 2.1. What is the ratio of the Imports(as % of merchandise exports) in Mozambique in 2000 to that in 2004?
Your answer should be very brief. 1.08. What is the ratio of the Imports(as % of merchandise exports) of Peru in 2000 to that in 2004?
Your answer should be compact. 0.92. What is the ratio of the Imports(as % of merchandise exports) in St. Kitts and Nevis in 2000 to that in 2004?
Ensure brevity in your answer.  1.34. What is the ratio of the Imports(as % of merchandise exports) in Burundi in 2001 to that in 2002?
Your response must be concise. 1.03. What is the ratio of the Imports(as % of merchandise exports) of Mozambique in 2001 to that in 2002?
Your answer should be very brief. 0.82. What is the ratio of the Imports(as % of merchandise exports) of Peru in 2001 to that in 2002?
Ensure brevity in your answer.  1.02. What is the ratio of the Imports(as % of merchandise exports) in St. Kitts and Nevis in 2001 to that in 2002?
Your answer should be very brief. 0.74. What is the ratio of the Imports(as % of merchandise exports) of Burundi in 2001 to that in 2003?
Provide a short and direct response. 1.94. What is the ratio of the Imports(as % of merchandise exports) in Mozambique in 2001 to that in 2003?
Give a very brief answer. 0.6. What is the ratio of the Imports(as % of merchandise exports) in Peru in 2001 to that in 2003?
Your answer should be very brief. 1.02. What is the ratio of the Imports(as % of merchandise exports) of St. Kitts and Nevis in 2001 to that in 2003?
Your response must be concise. 0.84. What is the ratio of the Imports(as % of merchandise exports) in Burundi in 2001 to that in 2004?
Your answer should be very brief. 2.21. What is the ratio of the Imports(as % of merchandise exports) in Mozambique in 2001 to that in 2004?
Your response must be concise. 0.56. What is the ratio of the Imports(as % of merchandise exports) in Peru in 2001 to that in 2004?
Offer a very short reply. 0.96. What is the ratio of the Imports(as % of merchandise exports) of St. Kitts and Nevis in 2001 to that in 2004?
Your answer should be compact. 1.05. What is the ratio of the Imports(as % of merchandise exports) in Burundi in 2002 to that in 2003?
Keep it short and to the point. 1.88. What is the ratio of the Imports(as % of merchandise exports) in Mozambique in 2002 to that in 2003?
Ensure brevity in your answer.  0.74. What is the ratio of the Imports(as % of merchandise exports) in St. Kitts and Nevis in 2002 to that in 2003?
Keep it short and to the point. 1.13. What is the ratio of the Imports(as % of merchandise exports) of Burundi in 2002 to that in 2004?
Provide a short and direct response. 2.15. What is the ratio of the Imports(as % of merchandise exports) of Mozambique in 2002 to that in 2004?
Offer a terse response. 0.68. What is the ratio of the Imports(as % of merchandise exports) in Peru in 2002 to that in 2004?
Give a very brief answer. 0.94. What is the ratio of the Imports(as % of merchandise exports) in St. Kitts and Nevis in 2002 to that in 2004?
Provide a succinct answer. 1.41. What is the ratio of the Imports(as % of merchandise exports) in Burundi in 2003 to that in 2004?
Make the answer very short. 1.14. What is the ratio of the Imports(as % of merchandise exports) in Mozambique in 2003 to that in 2004?
Your answer should be compact. 0.92. What is the ratio of the Imports(as % of merchandise exports) of Peru in 2003 to that in 2004?
Provide a succinct answer. 0.94. What is the ratio of the Imports(as % of merchandise exports) of St. Kitts and Nevis in 2003 to that in 2004?
Provide a short and direct response. 1.25. What is the difference between the highest and the second highest Imports(as % of merchandise exports) of Burundi?
Provide a succinct answer. 0.08. What is the difference between the highest and the second highest Imports(as % of merchandise exports) of Mozambique?
Provide a short and direct response. 1.04. What is the difference between the highest and the second highest Imports(as % of merchandise exports) of Peru?
Your answer should be very brief. 0.07. What is the difference between the highest and the second highest Imports(as % of merchandise exports) of St. Kitts and Nevis?
Your answer should be compact. 0.13. What is the difference between the highest and the lowest Imports(as % of merchandise exports) of Burundi?
Your response must be concise. 1.39. What is the difference between the highest and the lowest Imports(as % of merchandise exports) of Mozambique?
Provide a short and direct response. 1.67. What is the difference between the highest and the lowest Imports(as % of merchandise exports) of Peru?
Your response must be concise. 0.44. What is the difference between the highest and the lowest Imports(as % of merchandise exports) in St. Kitts and Nevis?
Provide a short and direct response. 0.78. 